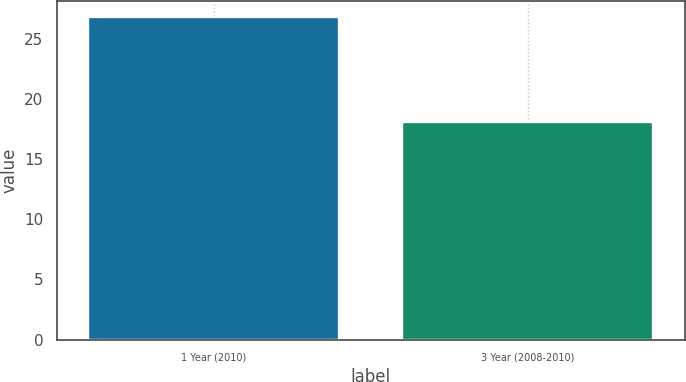Convert chart to OTSL. <chart><loc_0><loc_0><loc_500><loc_500><bar_chart><fcel>1 Year (2010)<fcel>3 Year (2008-2010)<nl><fcel>26.8<fcel>18.1<nl></chart> 